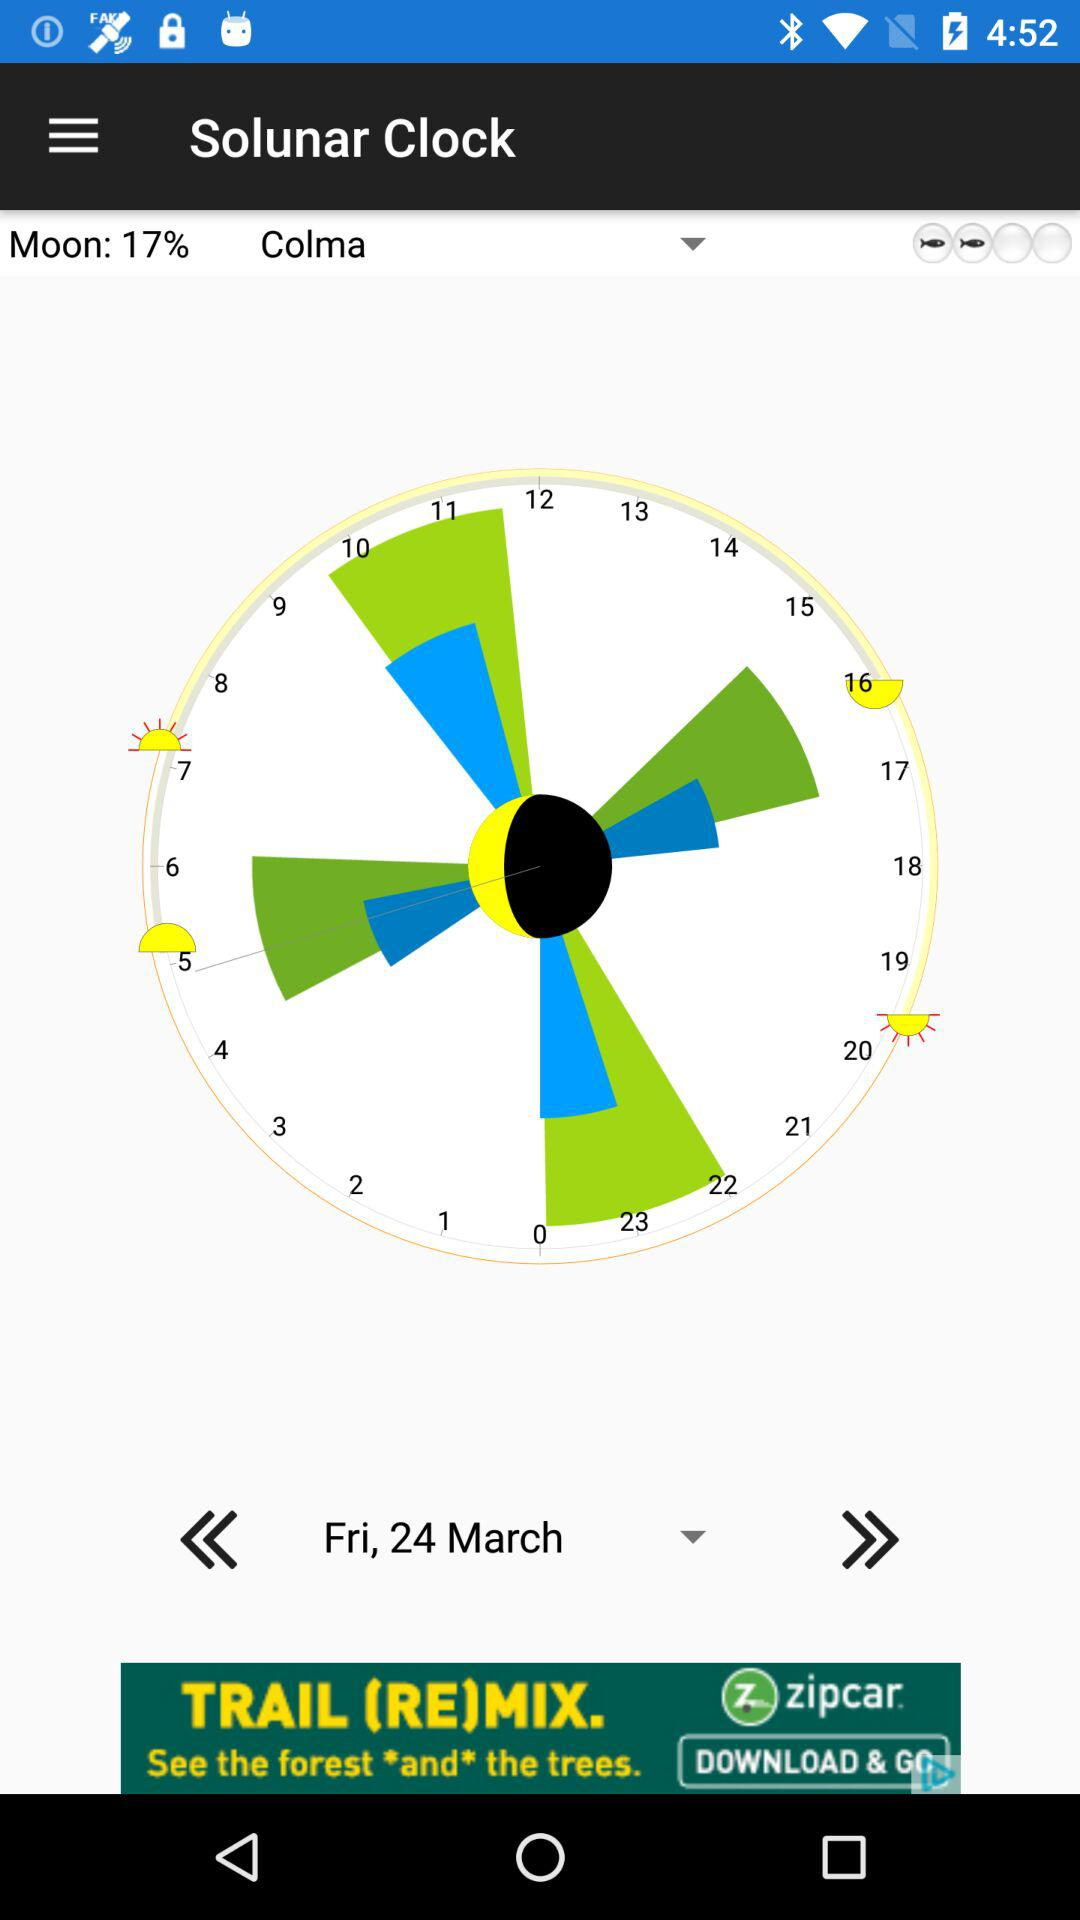Who is this application powered by?
When the provided information is insufficient, respond with <no answer>. <no answer> 